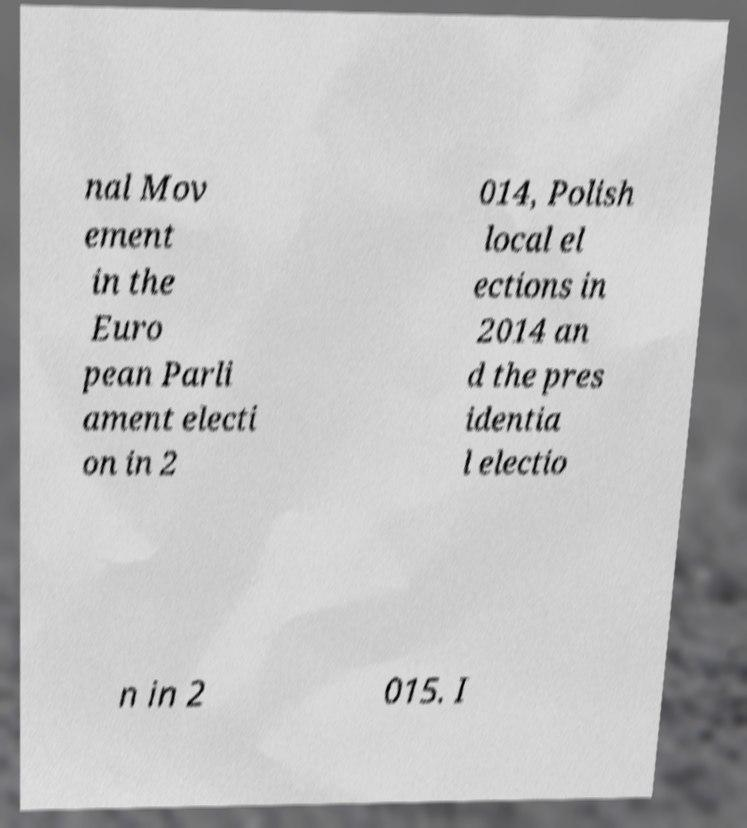For documentation purposes, I need the text within this image transcribed. Could you provide that? nal Mov ement in the Euro pean Parli ament electi on in 2 014, Polish local el ections in 2014 an d the pres identia l electio n in 2 015. I 